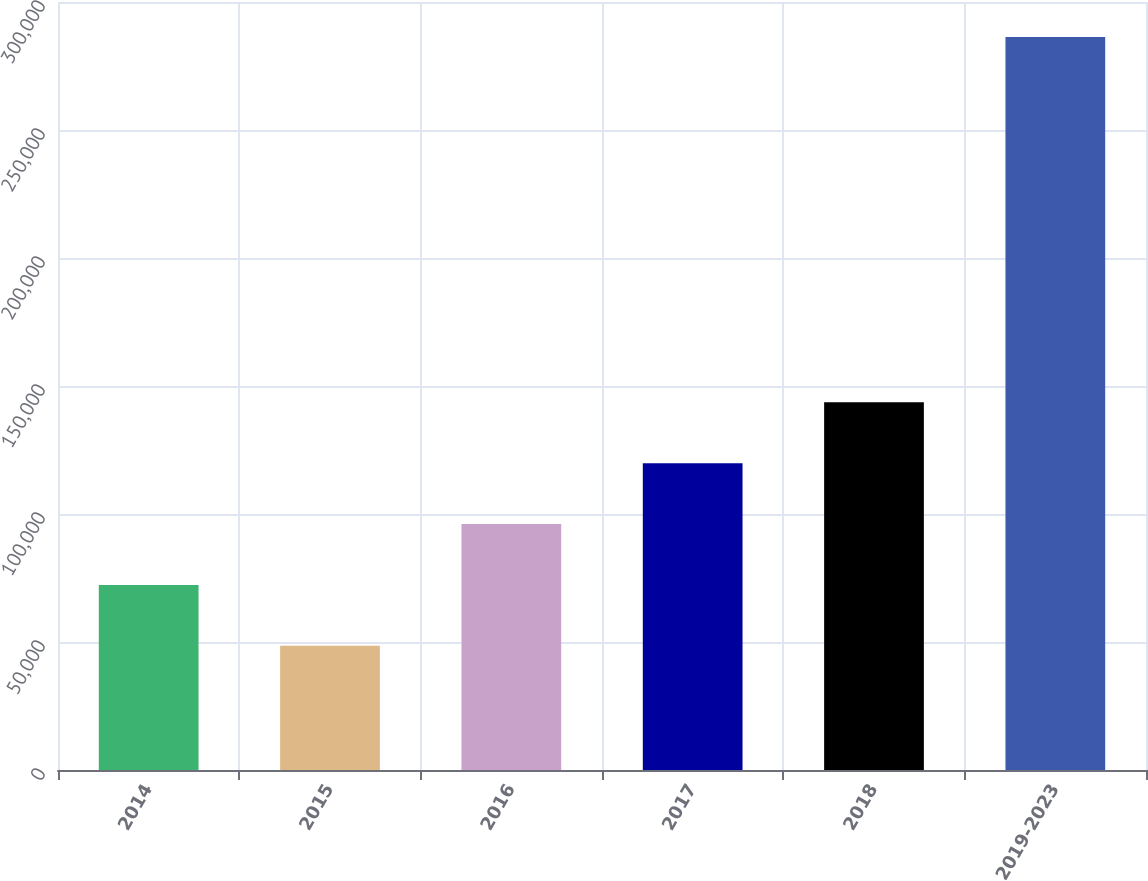Convert chart to OTSL. <chart><loc_0><loc_0><loc_500><loc_500><bar_chart><fcel>2014<fcel>2015<fcel>2016<fcel>2017<fcel>2018<fcel>2019-2023<nl><fcel>72282<fcel>48500<fcel>96064<fcel>119846<fcel>143628<fcel>286320<nl></chart> 